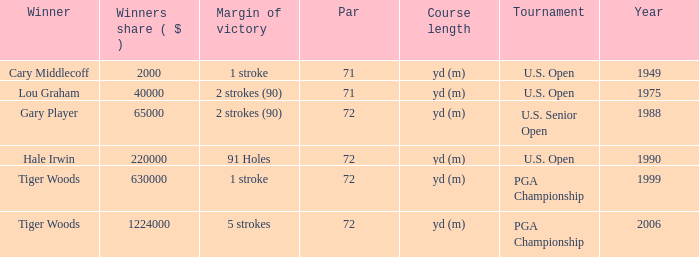When hale irwin is the winner what is the margin of victory? 91 Holes. Write the full table. {'header': ['Winner', 'Winners share ( $ )', 'Margin of victory', 'Par', 'Course length', 'Tournament', 'Year'], 'rows': [['Cary Middlecoff', '2000', '1 stroke', '71', 'yd (m)', 'U.S. Open', '1949'], ['Lou Graham', '40000', '2 strokes (90)', '71', 'yd (m)', 'U.S. Open', '1975'], ['Gary Player', '65000', '2 strokes (90)', '72', 'yd (m)', 'U.S. Senior Open', '1988'], ['Hale Irwin', '220000', '91 Holes', '72', 'yd (m)', 'U.S. Open', '1990'], ['Tiger Woods', '630000', '1 stroke', '72', 'yd (m)', 'PGA Championship', '1999'], ['Tiger Woods', '1224000', '5 strokes', '72', 'yd (m)', 'PGA Championship', '2006']]} 